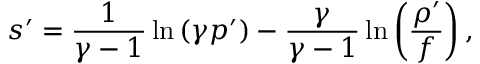<formula> <loc_0><loc_0><loc_500><loc_500>s ^ { \prime } = \frac { 1 } { \gamma - 1 } \ln \left ( \gamma p ^ { \prime } \right ) - \frac { \gamma } { \gamma - 1 } \ln \left ( \frac { \rho ^ { \prime } } { f } \right ) ,</formula> 